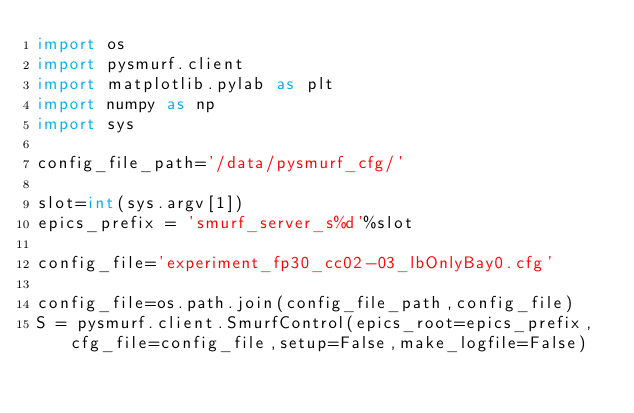<code> <loc_0><loc_0><loc_500><loc_500><_Python_>import os
import pysmurf.client
import matplotlib.pylab as plt
import numpy as np
import sys

config_file_path='/data/pysmurf_cfg/'

slot=int(sys.argv[1])
epics_prefix = 'smurf_server_s%d'%slot

config_file='experiment_fp30_cc02-03_lbOnlyBay0.cfg'

config_file=os.path.join(config_file_path,config_file)
S = pysmurf.client.SmurfControl(epics_root=epics_prefix,cfg_file=config_file,setup=False,make_logfile=False)

</code> 